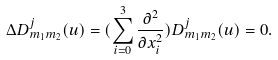<formula> <loc_0><loc_0><loc_500><loc_500>\Delta D ^ { j } _ { m _ { 1 } m _ { 2 } } ( u ) = ( \sum _ { i = 0 } ^ { 3 } \frac { \partial ^ { 2 } } { \partial x _ { i } ^ { 2 } } ) D ^ { j } _ { m _ { 1 } m _ { 2 } } ( u ) = 0 .</formula> 